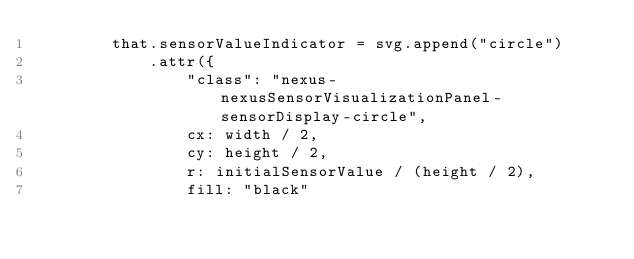Convert code to text. <code><loc_0><loc_0><loc_500><loc_500><_JavaScript_>        that.sensorValueIndicator = svg.append("circle")
            .attr({
                "class": "nexus-nexusSensorVisualizationPanel-sensorDisplay-circle",
                cx: width / 2,
                cy: height / 2,
                r: initialSensorValue / (height / 2),
                fill: "black"</code> 